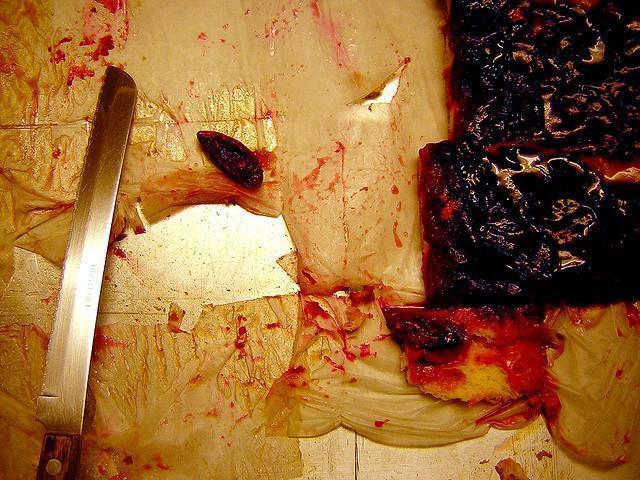How many cakes are in the picture?
Give a very brief answer. 2. 